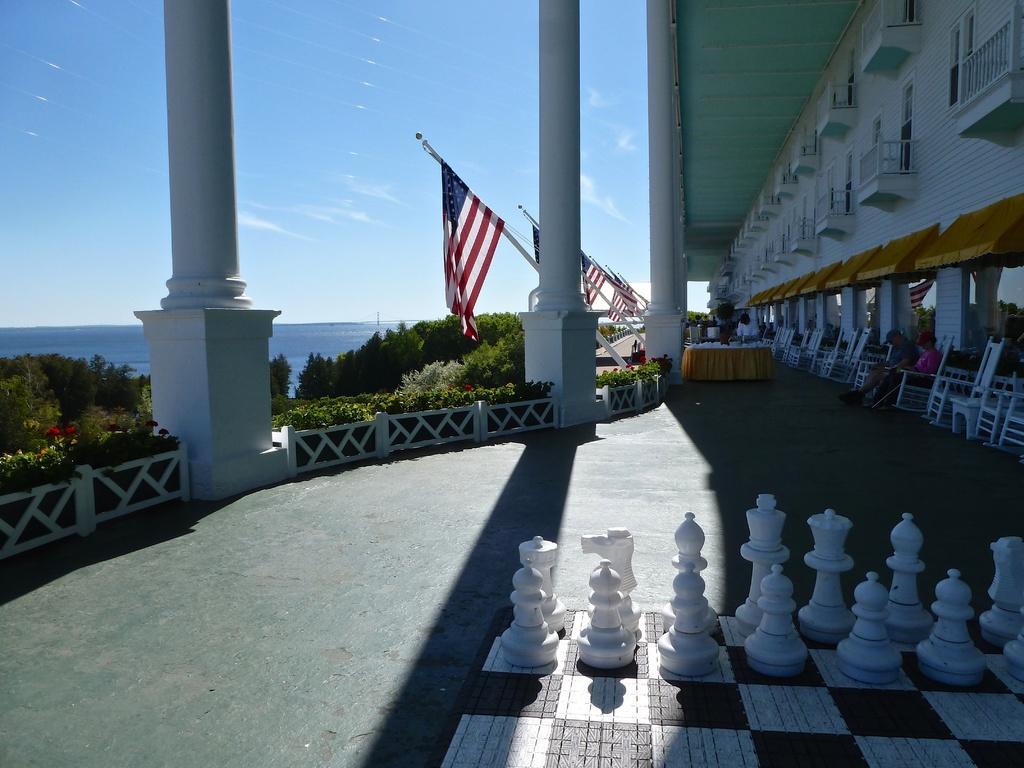How would you summarize this image in a sentence or two? In the picture I can see chess board, some chairs along with tables, we can see few people, some flags are attached to the building, outside of the building we can see plants, trees and sea. 